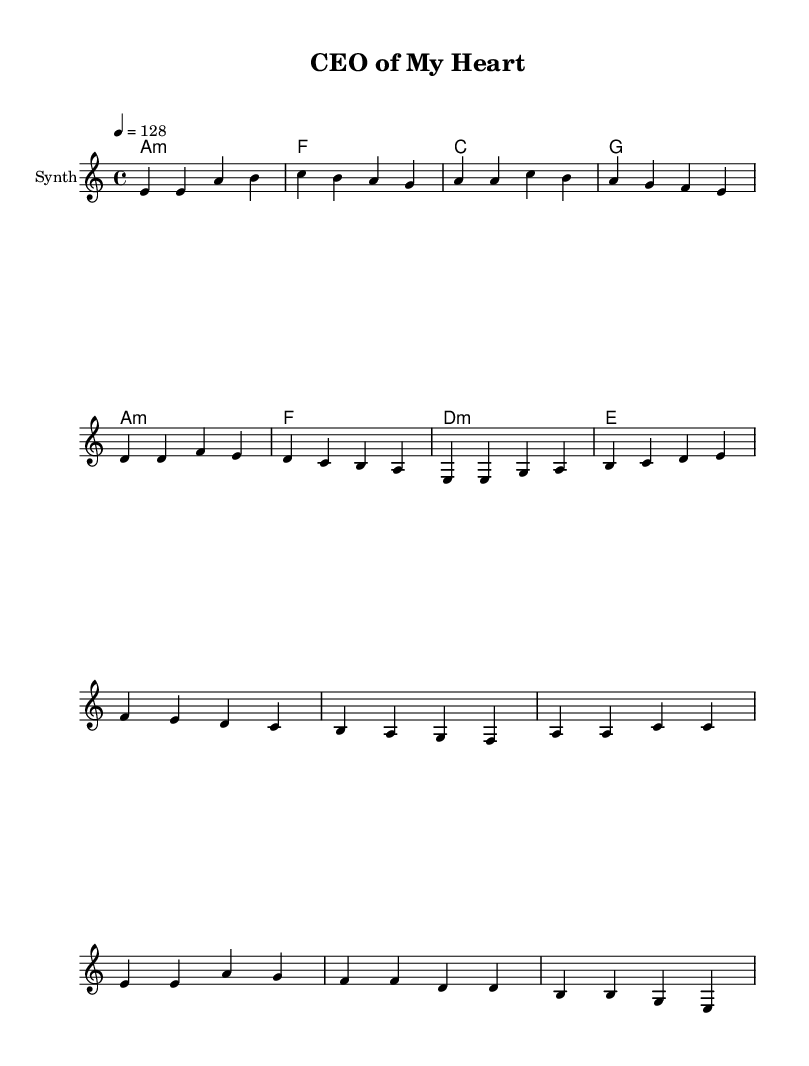What is the key signature of this music? The key signature is A minor, which contains no sharps or flats, indicated at the beginning of the sheet music.
Answer: A minor What is the time signature of this music? The time signature is 4/4, which is represented at the start of the score, indicating that there are four beats in each measure.
Answer: 4/4 What is the tempo marking for this piece? The tempo marking is 128 beats per minute, specified at the beginning of the score, indicating how fast the piece should be played.
Answer: 128 How many measures are in the verse section? The verse section consists of two measures, as seen in the melody section where the notes are grouped into two complete phrases.
Answer: 2 What is the final chord in the harmony section? The final chord in the harmony section is E major, which is the last chord listed in the harmonic progression at the end of the harmonies.
Answer: E What type of instrument is indicated for the melody? The instrument indicated for the melody is Synth, as noted at the beginning of the staff where the melody is written.
Answer: Synth What are the primary themes represented in this K-Pop piece? The themes of love and passion are represented in the title "CEO of My Heart," which suggests romantic undertones typical in K-Pop lyrics and concepts.
Answer: Love and passion 